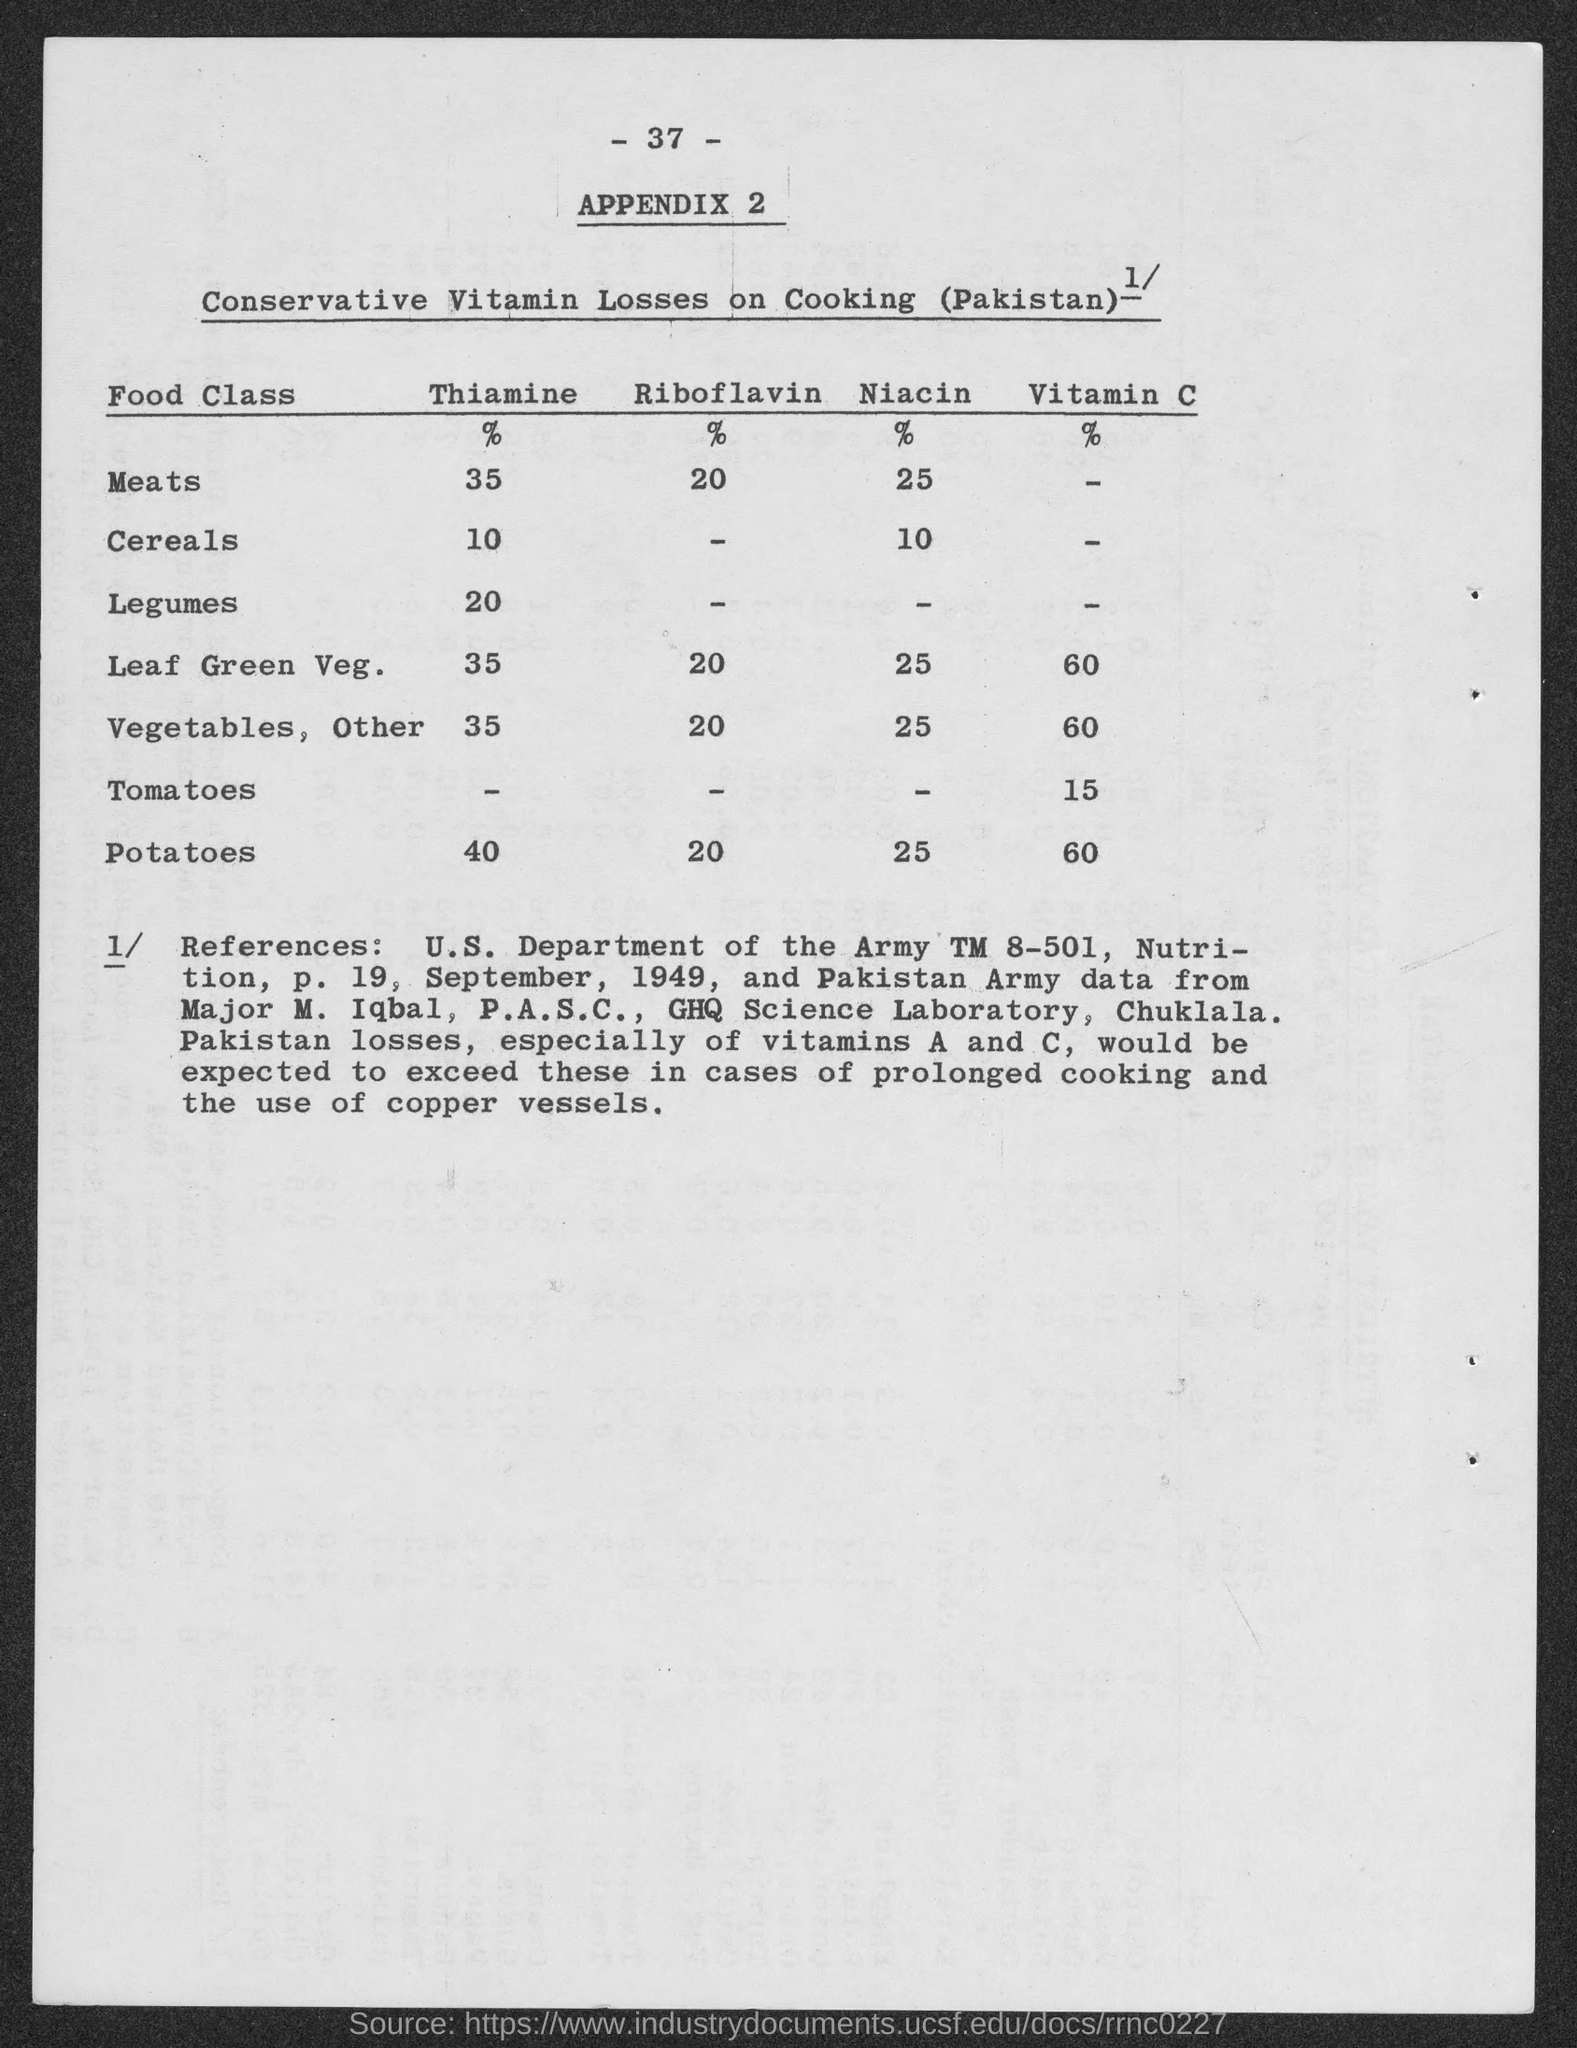What is the percentage of Thiamine in Meats?
Give a very brief answer. 35. What is the percentage of Riboflavin in Potatoes?
Your answer should be very brief. 20. What is the percentage of Niacin in Cereals?
Provide a short and direct response. 10. What percent of Vitamin C is available in Leaf Green Veg.?
Provide a short and direct response. 60. What percent of Thiamine is available in Legumes?
Make the answer very short. 20. What percent of Vitamin C is available in Tomatoes?
Your answer should be compact. 15. 